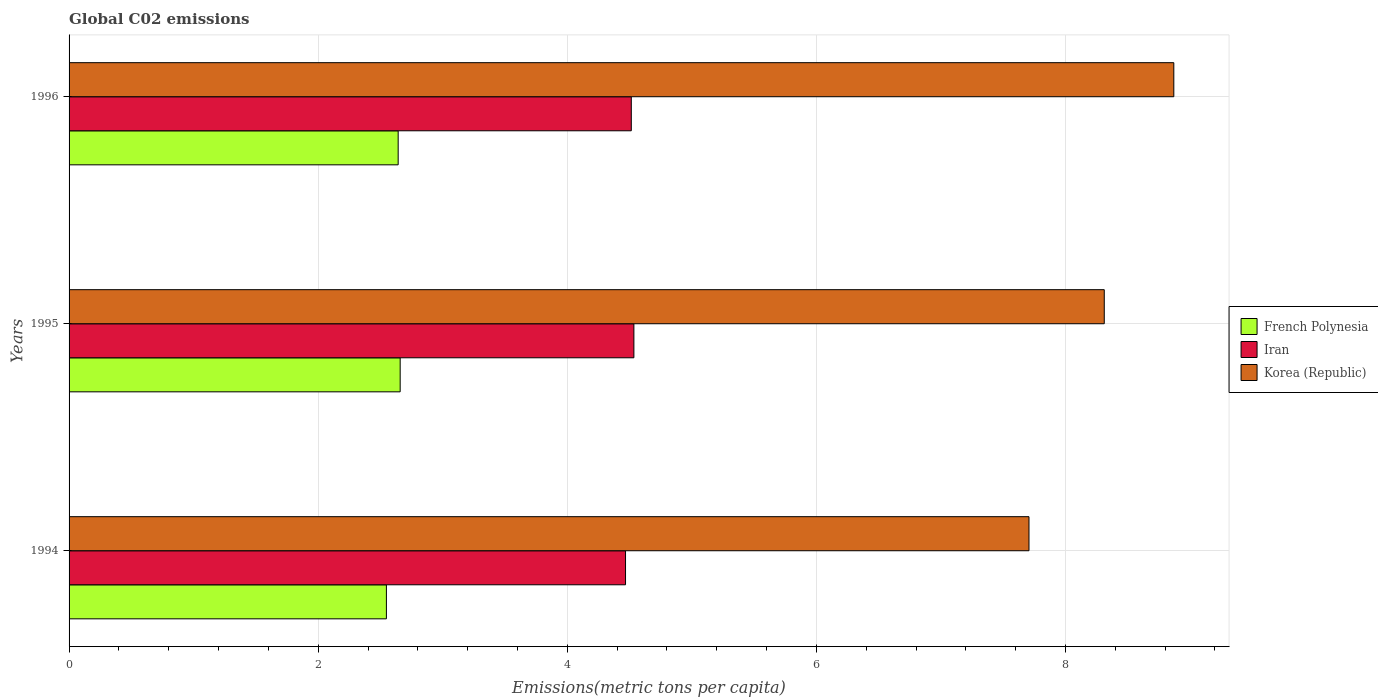How many groups of bars are there?
Your answer should be compact. 3. Are the number of bars per tick equal to the number of legend labels?
Offer a very short reply. Yes. Are the number of bars on each tick of the Y-axis equal?
Provide a short and direct response. Yes. How many bars are there on the 2nd tick from the top?
Offer a terse response. 3. In how many cases, is the number of bars for a given year not equal to the number of legend labels?
Offer a terse response. 0. What is the amount of CO2 emitted in in Iran in 1994?
Offer a terse response. 4.47. Across all years, what is the maximum amount of CO2 emitted in in Korea (Republic)?
Keep it short and to the point. 8.87. Across all years, what is the minimum amount of CO2 emitted in in French Polynesia?
Ensure brevity in your answer.  2.55. In which year was the amount of CO2 emitted in in Korea (Republic) maximum?
Give a very brief answer. 1996. What is the total amount of CO2 emitted in in Korea (Republic) in the graph?
Make the answer very short. 24.89. What is the difference between the amount of CO2 emitted in in Korea (Republic) in 1995 and that in 1996?
Your answer should be very brief. -0.56. What is the difference between the amount of CO2 emitted in in Korea (Republic) in 1996 and the amount of CO2 emitted in in French Polynesia in 1995?
Make the answer very short. 6.21. What is the average amount of CO2 emitted in in Korea (Republic) per year?
Your response must be concise. 8.3. In the year 1996, what is the difference between the amount of CO2 emitted in in Korea (Republic) and amount of CO2 emitted in in Iran?
Your response must be concise. 4.36. What is the ratio of the amount of CO2 emitted in in Korea (Republic) in 1994 to that in 1996?
Your answer should be very brief. 0.87. Is the amount of CO2 emitted in in Iran in 1994 less than that in 1995?
Your response must be concise. Yes. What is the difference between the highest and the second highest amount of CO2 emitted in in Iran?
Your answer should be very brief. 0.02. What is the difference between the highest and the lowest amount of CO2 emitted in in Iran?
Your answer should be compact. 0.07. In how many years, is the amount of CO2 emitted in in Iran greater than the average amount of CO2 emitted in in Iran taken over all years?
Give a very brief answer. 2. Is the sum of the amount of CO2 emitted in in French Polynesia in 1994 and 1996 greater than the maximum amount of CO2 emitted in in Korea (Republic) across all years?
Provide a succinct answer. No. What does the 1st bar from the bottom in 1996 represents?
Provide a short and direct response. French Polynesia. Is it the case that in every year, the sum of the amount of CO2 emitted in in Iran and amount of CO2 emitted in in French Polynesia is greater than the amount of CO2 emitted in in Korea (Republic)?
Make the answer very short. No. Does the graph contain grids?
Make the answer very short. Yes. Where does the legend appear in the graph?
Your response must be concise. Center right. How many legend labels are there?
Your answer should be compact. 3. What is the title of the graph?
Provide a succinct answer. Global C02 emissions. What is the label or title of the X-axis?
Give a very brief answer. Emissions(metric tons per capita). What is the Emissions(metric tons per capita) in French Polynesia in 1994?
Give a very brief answer. 2.55. What is the Emissions(metric tons per capita) of Iran in 1994?
Keep it short and to the point. 4.47. What is the Emissions(metric tons per capita) in Korea (Republic) in 1994?
Give a very brief answer. 7.71. What is the Emissions(metric tons per capita) in French Polynesia in 1995?
Keep it short and to the point. 2.66. What is the Emissions(metric tons per capita) of Iran in 1995?
Make the answer very short. 4.53. What is the Emissions(metric tons per capita) of Korea (Republic) in 1995?
Keep it short and to the point. 8.31. What is the Emissions(metric tons per capita) of French Polynesia in 1996?
Your answer should be very brief. 2.64. What is the Emissions(metric tons per capita) in Iran in 1996?
Provide a succinct answer. 4.51. What is the Emissions(metric tons per capita) of Korea (Republic) in 1996?
Offer a terse response. 8.87. Across all years, what is the maximum Emissions(metric tons per capita) in French Polynesia?
Your response must be concise. 2.66. Across all years, what is the maximum Emissions(metric tons per capita) in Iran?
Provide a succinct answer. 4.53. Across all years, what is the maximum Emissions(metric tons per capita) of Korea (Republic)?
Provide a short and direct response. 8.87. Across all years, what is the minimum Emissions(metric tons per capita) in French Polynesia?
Ensure brevity in your answer.  2.55. Across all years, what is the minimum Emissions(metric tons per capita) in Iran?
Keep it short and to the point. 4.47. Across all years, what is the minimum Emissions(metric tons per capita) in Korea (Republic)?
Provide a succinct answer. 7.71. What is the total Emissions(metric tons per capita) of French Polynesia in the graph?
Keep it short and to the point. 7.85. What is the total Emissions(metric tons per capita) in Iran in the graph?
Offer a terse response. 13.52. What is the total Emissions(metric tons per capita) in Korea (Republic) in the graph?
Your answer should be compact. 24.89. What is the difference between the Emissions(metric tons per capita) of French Polynesia in 1994 and that in 1995?
Keep it short and to the point. -0.11. What is the difference between the Emissions(metric tons per capita) of Iran in 1994 and that in 1995?
Your answer should be very brief. -0.07. What is the difference between the Emissions(metric tons per capita) of Korea (Republic) in 1994 and that in 1995?
Give a very brief answer. -0.6. What is the difference between the Emissions(metric tons per capita) in French Polynesia in 1994 and that in 1996?
Keep it short and to the point. -0.09. What is the difference between the Emissions(metric tons per capita) in Iran in 1994 and that in 1996?
Give a very brief answer. -0.05. What is the difference between the Emissions(metric tons per capita) of Korea (Republic) in 1994 and that in 1996?
Your response must be concise. -1.16. What is the difference between the Emissions(metric tons per capita) in French Polynesia in 1995 and that in 1996?
Your answer should be compact. 0.02. What is the difference between the Emissions(metric tons per capita) in Iran in 1995 and that in 1996?
Your answer should be very brief. 0.02. What is the difference between the Emissions(metric tons per capita) in Korea (Republic) in 1995 and that in 1996?
Offer a very short reply. -0.56. What is the difference between the Emissions(metric tons per capita) of French Polynesia in 1994 and the Emissions(metric tons per capita) of Iran in 1995?
Provide a short and direct response. -1.99. What is the difference between the Emissions(metric tons per capita) of French Polynesia in 1994 and the Emissions(metric tons per capita) of Korea (Republic) in 1995?
Your answer should be very brief. -5.76. What is the difference between the Emissions(metric tons per capita) in Iran in 1994 and the Emissions(metric tons per capita) in Korea (Republic) in 1995?
Keep it short and to the point. -3.84. What is the difference between the Emissions(metric tons per capita) in French Polynesia in 1994 and the Emissions(metric tons per capita) in Iran in 1996?
Make the answer very short. -1.97. What is the difference between the Emissions(metric tons per capita) in French Polynesia in 1994 and the Emissions(metric tons per capita) in Korea (Republic) in 1996?
Your answer should be compact. -6.32. What is the difference between the Emissions(metric tons per capita) of Iran in 1994 and the Emissions(metric tons per capita) of Korea (Republic) in 1996?
Ensure brevity in your answer.  -4.4. What is the difference between the Emissions(metric tons per capita) of French Polynesia in 1995 and the Emissions(metric tons per capita) of Iran in 1996?
Your answer should be compact. -1.86. What is the difference between the Emissions(metric tons per capita) in French Polynesia in 1995 and the Emissions(metric tons per capita) in Korea (Republic) in 1996?
Give a very brief answer. -6.21. What is the difference between the Emissions(metric tons per capita) in Iran in 1995 and the Emissions(metric tons per capita) in Korea (Republic) in 1996?
Provide a short and direct response. -4.33. What is the average Emissions(metric tons per capita) of French Polynesia per year?
Provide a succinct answer. 2.62. What is the average Emissions(metric tons per capita) in Iran per year?
Your response must be concise. 4.51. What is the average Emissions(metric tons per capita) in Korea (Republic) per year?
Provide a short and direct response. 8.3. In the year 1994, what is the difference between the Emissions(metric tons per capita) in French Polynesia and Emissions(metric tons per capita) in Iran?
Provide a succinct answer. -1.92. In the year 1994, what is the difference between the Emissions(metric tons per capita) of French Polynesia and Emissions(metric tons per capita) of Korea (Republic)?
Give a very brief answer. -5.16. In the year 1994, what is the difference between the Emissions(metric tons per capita) of Iran and Emissions(metric tons per capita) of Korea (Republic)?
Give a very brief answer. -3.24. In the year 1995, what is the difference between the Emissions(metric tons per capita) in French Polynesia and Emissions(metric tons per capita) in Iran?
Ensure brevity in your answer.  -1.88. In the year 1995, what is the difference between the Emissions(metric tons per capita) in French Polynesia and Emissions(metric tons per capita) in Korea (Republic)?
Provide a succinct answer. -5.65. In the year 1995, what is the difference between the Emissions(metric tons per capita) in Iran and Emissions(metric tons per capita) in Korea (Republic)?
Give a very brief answer. -3.78. In the year 1996, what is the difference between the Emissions(metric tons per capita) in French Polynesia and Emissions(metric tons per capita) in Iran?
Make the answer very short. -1.87. In the year 1996, what is the difference between the Emissions(metric tons per capita) in French Polynesia and Emissions(metric tons per capita) in Korea (Republic)?
Make the answer very short. -6.23. In the year 1996, what is the difference between the Emissions(metric tons per capita) in Iran and Emissions(metric tons per capita) in Korea (Republic)?
Provide a succinct answer. -4.36. What is the ratio of the Emissions(metric tons per capita) of French Polynesia in 1994 to that in 1995?
Provide a succinct answer. 0.96. What is the ratio of the Emissions(metric tons per capita) in Iran in 1994 to that in 1995?
Ensure brevity in your answer.  0.99. What is the ratio of the Emissions(metric tons per capita) of Korea (Republic) in 1994 to that in 1995?
Your answer should be compact. 0.93. What is the ratio of the Emissions(metric tons per capita) in French Polynesia in 1994 to that in 1996?
Make the answer very short. 0.96. What is the ratio of the Emissions(metric tons per capita) of Iran in 1994 to that in 1996?
Provide a short and direct response. 0.99. What is the ratio of the Emissions(metric tons per capita) of Korea (Republic) in 1994 to that in 1996?
Make the answer very short. 0.87. What is the ratio of the Emissions(metric tons per capita) of Iran in 1995 to that in 1996?
Offer a terse response. 1. What is the ratio of the Emissions(metric tons per capita) of Korea (Republic) in 1995 to that in 1996?
Provide a succinct answer. 0.94. What is the difference between the highest and the second highest Emissions(metric tons per capita) of French Polynesia?
Your answer should be compact. 0.02. What is the difference between the highest and the second highest Emissions(metric tons per capita) in Iran?
Provide a succinct answer. 0.02. What is the difference between the highest and the second highest Emissions(metric tons per capita) of Korea (Republic)?
Keep it short and to the point. 0.56. What is the difference between the highest and the lowest Emissions(metric tons per capita) of French Polynesia?
Ensure brevity in your answer.  0.11. What is the difference between the highest and the lowest Emissions(metric tons per capita) of Iran?
Offer a very short reply. 0.07. What is the difference between the highest and the lowest Emissions(metric tons per capita) of Korea (Republic)?
Offer a terse response. 1.16. 